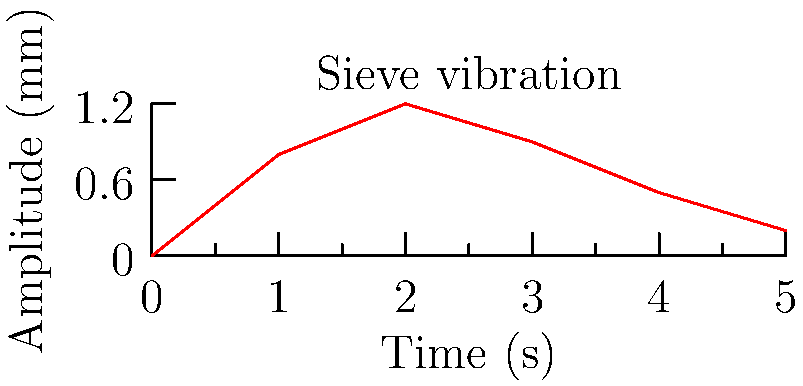A mechanical sieve used for sorting medicinal plant materials exhibits the vibration pattern shown in the graph. If the natural frequency of the sieve is 2 Hz, what is the maximum amplitude of forced vibration, and at what time does it occur? To solve this problem, we need to analyze the given vibration graph:

1. The graph shows the amplitude of vibration over time.
2. We need to identify the maximum amplitude and its corresponding time.

Analyzing the graph:
1. The y-axis represents the amplitude in millimeters.
2. The x-axis represents time in seconds.
3. The maximum point on the graph occurs at (2, 1.2).

Therefore:
- The maximum amplitude is 1.2 mm.
- This maximum amplitude occurs at t = 2 seconds.

Note: The natural frequency of 2 Hz given in the question is not directly used in this solution but is relevant for understanding the system's behavior. In a forced vibration scenario, the maximum amplitude often occurs when the forcing frequency is close to the natural frequency, which might explain the peak at 2 seconds.
Answer: Maximum amplitude: 1.2 mm at t = 2 s 